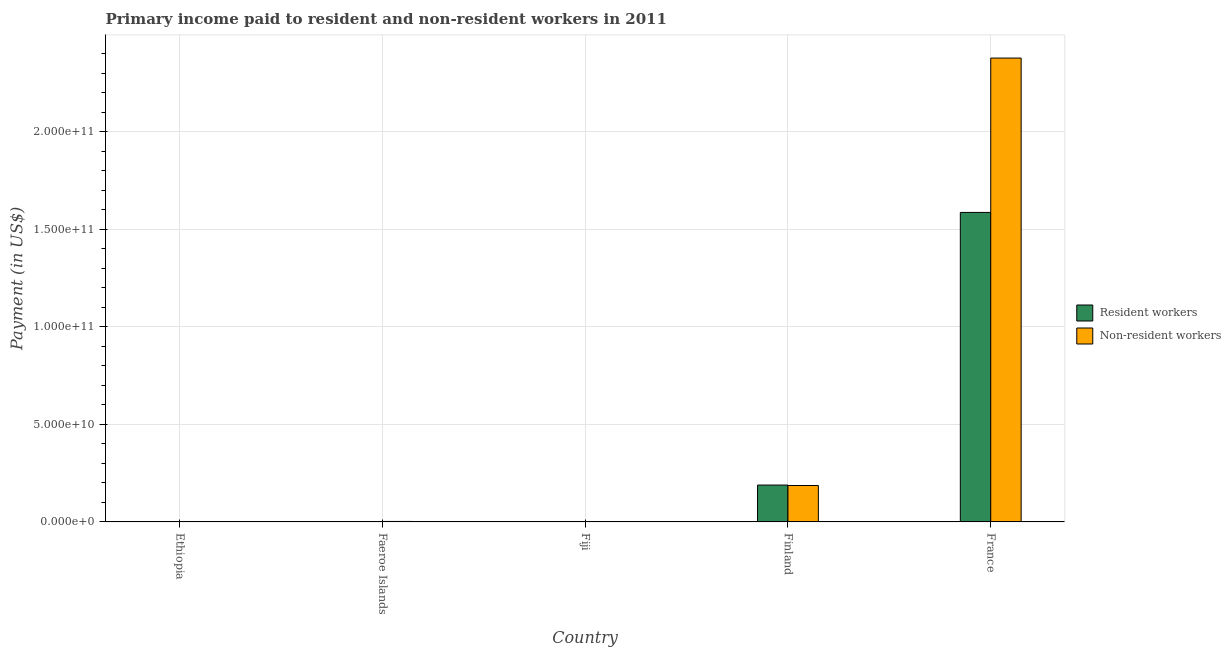How many groups of bars are there?
Your answer should be compact. 5. Are the number of bars on each tick of the X-axis equal?
Make the answer very short. Yes. How many bars are there on the 3rd tick from the right?
Provide a short and direct response. 2. What is the label of the 1st group of bars from the left?
Your response must be concise. Ethiopia. In how many cases, is the number of bars for a given country not equal to the number of legend labels?
Offer a very short reply. 0. What is the payment made to resident workers in Faeroe Islands?
Your answer should be compact. 1.17e+08. Across all countries, what is the maximum payment made to resident workers?
Offer a terse response. 1.59e+11. Across all countries, what is the minimum payment made to non-resident workers?
Make the answer very short. 8.80e+06. In which country was the payment made to non-resident workers minimum?
Make the answer very short. Ethiopia. What is the total payment made to non-resident workers in the graph?
Ensure brevity in your answer.  2.57e+11. What is the difference between the payment made to non-resident workers in Fiji and that in Finland?
Give a very brief answer. -1.86e+1. What is the difference between the payment made to non-resident workers in Faeroe Islands and the payment made to resident workers in Finland?
Keep it short and to the point. -1.87e+1. What is the average payment made to non-resident workers per country?
Provide a short and direct response. 5.14e+1. What is the difference between the payment made to non-resident workers and payment made to resident workers in Faeroe Islands?
Provide a succinct answer. 1.22e+08. What is the ratio of the payment made to non-resident workers in Faeroe Islands to that in Fiji?
Provide a succinct answer. 2.41. What is the difference between the highest and the second highest payment made to non-resident workers?
Your response must be concise. 2.19e+11. What is the difference between the highest and the lowest payment made to resident workers?
Ensure brevity in your answer.  1.59e+11. In how many countries, is the payment made to resident workers greater than the average payment made to resident workers taken over all countries?
Offer a terse response. 1. Is the sum of the payment made to non-resident workers in Faeroe Islands and Fiji greater than the maximum payment made to resident workers across all countries?
Keep it short and to the point. No. What does the 2nd bar from the left in Ethiopia represents?
Provide a short and direct response. Non-resident workers. What does the 2nd bar from the right in France represents?
Provide a succinct answer. Resident workers. How many bars are there?
Keep it short and to the point. 10. Does the graph contain grids?
Keep it short and to the point. Yes. What is the title of the graph?
Your answer should be very brief. Primary income paid to resident and non-resident workers in 2011. What is the label or title of the Y-axis?
Your response must be concise. Payment (in US$). What is the Payment (in US$) of Resident workers in Ethiopia?
Your answer should be very brief. 8.56e+07. What is the Payment (in US$) in Non-resident workers in Ethiopia?
Your answer should be very brief. 8.80e+06. What is the Payment (in US$) of Resident workers in Faeroe Islands?
Your answer should be very brief. 1.17e+08. What is the Payment (in US$) in Non-resident workers in Faeroe Islands?
Your answer should be compact. 2.39e+08. What is the Payment (in US$) of Resident workers in Fiji?
Your answer should be very brief. 2.17e+08. What is the Payment (in US$) in Non-resident workers in Fiji?
Give a very brief answer. 9.91e+07. What is the Payment (in US$) of Resident workers in Finland?
Ensure brevity in your answer.  1.89e+1. What is the Payment (in US$) of Non-resident workers in Finland?
Provide a succinct answer. 1.87e+1. What is the Payment (in US$) of Resident workers in France?
Make the answer very short. 1.59e+11. What is the Payment (in US$) of Non-resident workers in France?
Your answer should be very brief. 2.38e+11. Across all countries, what is the maximum Payment (in US$) in Resident workers?
Your response must be concise. 1.59e+11. Across all countries, what is the maximum Payment (in US$) in Non-resident workers?
Keep it short and to the point. 2.38e+11. Across all countries, what is the minimum Payment (in US$) of Resident workers?
Keep it short and to the point. 8.56e+07. Across all countries, what is the minimum Payment (in US$) of Non-resident workers?
Offer a very short reply. 8.80e+06. What is the total Payment (in US$) of Resident workers in the graph?
Give a very brief answer. 1.78e+11. What is the total Payment (in US$) of Non-resident workers in the graph?
Your answer should be compact. 2.57e+11. What is the difference between the Payment (in US$) of Resident workers in Ethiopia and that in Faeroe Islands?
Give a very brief answer. -3.13e+07. What is the difference between the Payment (in US$) of Non-resident workers in Ethiopia and that in Faeroe Islands?
Ensure brevity in your answer.  -2.30e+08. What is the difference between the Payment (in US$) in Resident workers in Ethiopia and that in Fiji?
Give a very brief answer. -1.31e+08. What is the difference between the Payment (in US$) in Non-resident workers in Ethiopia and that in Fiji?
Give a very brief answer. -9.03e+07. What is the difference between the Payment (in US$) of Resident workers in Ethiopia and that in Finland?
Ensure brevity in your answer.  -1.88e+1. What is the difference between the Payment (in US$) in Non-resident workers in Ethiopia and that in Finland?
Your response must be concise. -1.87e+1. What is the difference between the Payment (in US$) in Resident workers in Ethiopia and that in France?
Offer a terse response. -1.59e+11. What is the difference between the Payment (in US$) of Non-resident workers in Ethiopia and that in France?
Ensure brevity in your answer.  -2.38e+11. What is the difference between the Payment (in US$) in Resident workers in Faeroe Islands and that in Fiji?
Make the answer very short. -9.96e+07. What is the difference between the Payment (in US$) of Non-resident workers in Faeroe Islands and that in Fiji?
Offer a terse response. 1.40e+08. What is the difference between the Payment (in US$) of Resident workers in Faeroe Islands and that in Finland?
Your answer should be compact. -1.88e+1. What is the difference between the Payment (in US$) of Non-resident workers in Faeroe Islands and that in Finland?
Offer a terse response. -1.84e+1. What is the difference between the Payment (in US$) in Resident workers in Faeroe Islands and that in France?
Provide a succinct answer. -1.59e+11. What is the difference between the Payment (in US$) in Non-resident workers in Faeroe Islands and that in France?
Ensure brevity in your answer.  -2.38e+11. What is the difference between the Payment (in US$) in Resident workers in Fiji and that in Finland?
Make the answer very short. -1.87e+1. What is the difference between the Payment (in US$) in Non-resident workers in Fiji and that in Finland?
Offer a very short reply. -1.86e+1. What is the difference between the Payment (in US$) in Resident workers in Fiji and that in France?
Your answer should be very brief. -1.58e+11. What is the difference between the Payment (in US$) in Non-resident workers in Fiji and that in France?
Your response must be concise. -2.38e+11. What is the difference between the Payment (in US$) of Resident workers in Finland and that in France?
Your answer should be very brief. -1.40e+11. What is the difference between the Payment (in US$) in Non-resident workers in Finland and that in France?
Keep it short and to the point. -2.19e+11. What is the difference between the Payment (in US$) in Resident workers in Ethiopia and the Payment (in US$) in Non-resident workers in Faeroe Islands?
Provide a short and direct response. -1.53e+08. What is the difference between the Payment (in US$) of Resident workers in Ethiopia and the Payment (in US$) of Non-resident workers in Fiji?
Provide a short and direct response. -1.34e+07. What is the difference between the Payment (in US$) in Resident workers in Ethiopia and the Payment (in US$) in Non-resident workers in Finland?
Give a very brief answer. -1.86e+1. What is the difference between the Payment (in US$) in Resident workers in Ethiopia and the Payment (in US$) in Non-resident workers in France?
Your answer should be very brief. -2.38e+11. What is the difference between the Payment (in US$) of Resident workers in Faeroe Islands and the Payment (in US$) of Non-resident workers in Fiji?
Provide a short and direct response. 1.79e+07. What is the difference between the Payment (in US$) of Resident workers in Faeroe Islands and the Payment (in US$) of Non-resident workers in Finland?
Provide a succinct answer. -1.86e+1. What is the difference between the Payment (in US$) of Resident workers in Faeroe Islands and the Payment (in US$) of Non-resident workers in France?
Your answer should be compact. -2.38e+11. What is the difference between the Payment (in US$) of Resident workers in Fiji and the Payment (in US$) of Non-resident workers in Finland?
Provide a succinct answer. -1.85e+1. What is the difference between the Payment (in US$) in Resident workers in Fiji and the Payment (in US$) in Non-resident workers in France?
Your answer should be very brief. -2.38e+11. What is the difference between the Payment (in US$) in Resident workers in Finland and the Payment (in US$) in Non-resident workers in France?
Ensure brevity in your answer.  -2.19e+11. What is the average Payment (in US$) of Resident workers per country?
Your answer should be very brief. 3.56e+1. What is the average Payment (in US$) of Non-resident workers per country?
Your response must be concise. 5.14e+1. What is the difference between the Payment (in US$) in Resident workers and Payment (in US$) in Non-resident workers in Ethiopia?
Ensure brevity in your answer.  7.68e+07. What is the difference between the Payment (in US$) in Resident workers and Payment (in US$) in Non-resident workers in Faeroe Islands?
Provide a short and direct response. -1.22e+08. What is the difference between the Payment (in US$) in Resident workers and Payment (in US$) in Non-resident workers in Fiji?
Provide a short and direct response. 1.18e+08. What is the difference between the Payment (in US$) of Resident workers and Payment (in US$) of Non-resident workers in Finland?
Offer a terse response. 2.26e+08. What is the difference between the Payment (in US$) of Resident workers and Payment (in US$) of Non-resident workers in France?
Keep it short and to the point. -7.91e+1. What is the ratio of the Payment (in US$) in Resident workers in Ethiopia to that in Faeroe Islands?
Your answer should be compact. 0.73. What is the ratio of the Payment (in US$) of Non-resident workers in Ethiopia to that in Faeroe Islands?
Make the answer very short. 0.04. What is the ratio of the Payment (in US$) of Resident workers in Ethiopia to that in Fiji?
Your answer should be compact. 0.4. What is the ratio of the Payment (in US$) in Non-resident workers in Ethiopia to that in Fiji?
Provide a succinct answer. 0.09. What is the ratio of the Payment (in US$) of Resident workers in Ethiopia to that in Finland?
Offer a terse response. 0. What is the ratio of the Payment (in US$) in Non-resident workers in Ethiopia to that in France?
Offer a very short reply. 0. What is the ratio of the Payment (in US$) in Resident workers in Faeroe Islands to that in Fiji?
Your answer should be compact. 0.54. What is the ratio of the Payment (in US$) of Non-resident workers in Faeroe Islands to that in Fiji?
Ensure brevity in your answer.  2.41. What is the ratio of the Payment (in US$) in Resident workers in Faeroe Islands to that in Finland?
Give a very brief answer. 0.01. What is the ratio of the Payment (in US$) of Non-resident workers in Faeroe Islands to that in Finland?
Keep it short and to the point. 0.01. What is the ratio of the Payment (in US$) in Resident workers in Faeroe Islands to that in France?
Ensure brevity in your answer.  0. What is the ratio of the Payment (in US$) in Resident workers in Fiji to that in Finland?
Ensure brevity in your answer.  0.01. What is the ratio of the Payment (in US$) in Non-resident workers in Fiji to that in Finland?
Provide a short and direct response. 0.01. What is the ratio of the Payment (in US$) in Resident workers in Fiji to that in France?
Offer a terse response. 0. What is the ratio of the Payment (in US$) in Resident workers in Finland to that in France?
Ensure brevity in your answer.  0.12. What is the ratio of the Payment (in US$) of Non-resident workers in Finland to that in France?
Your answer should be very brief. 0.08. What is the difference between the highest and the second highest Payment (in US$) in Resident workers?
Offer a very short reply. 1.40e+11. What is the difference between the highest and the second highest Payment (in US$) in Non-resident workers?
Your answer should be compact. 2.19e+11. What is the difference between the highest and the lowest Payment (in US$) in Resident workers?
Your answer should be very brief. 1.59e+11. What is the difference between the highest and the lowest Payment (in US$) in Non-resident workers?
Provide a succinct answer. 2.38e+11. 